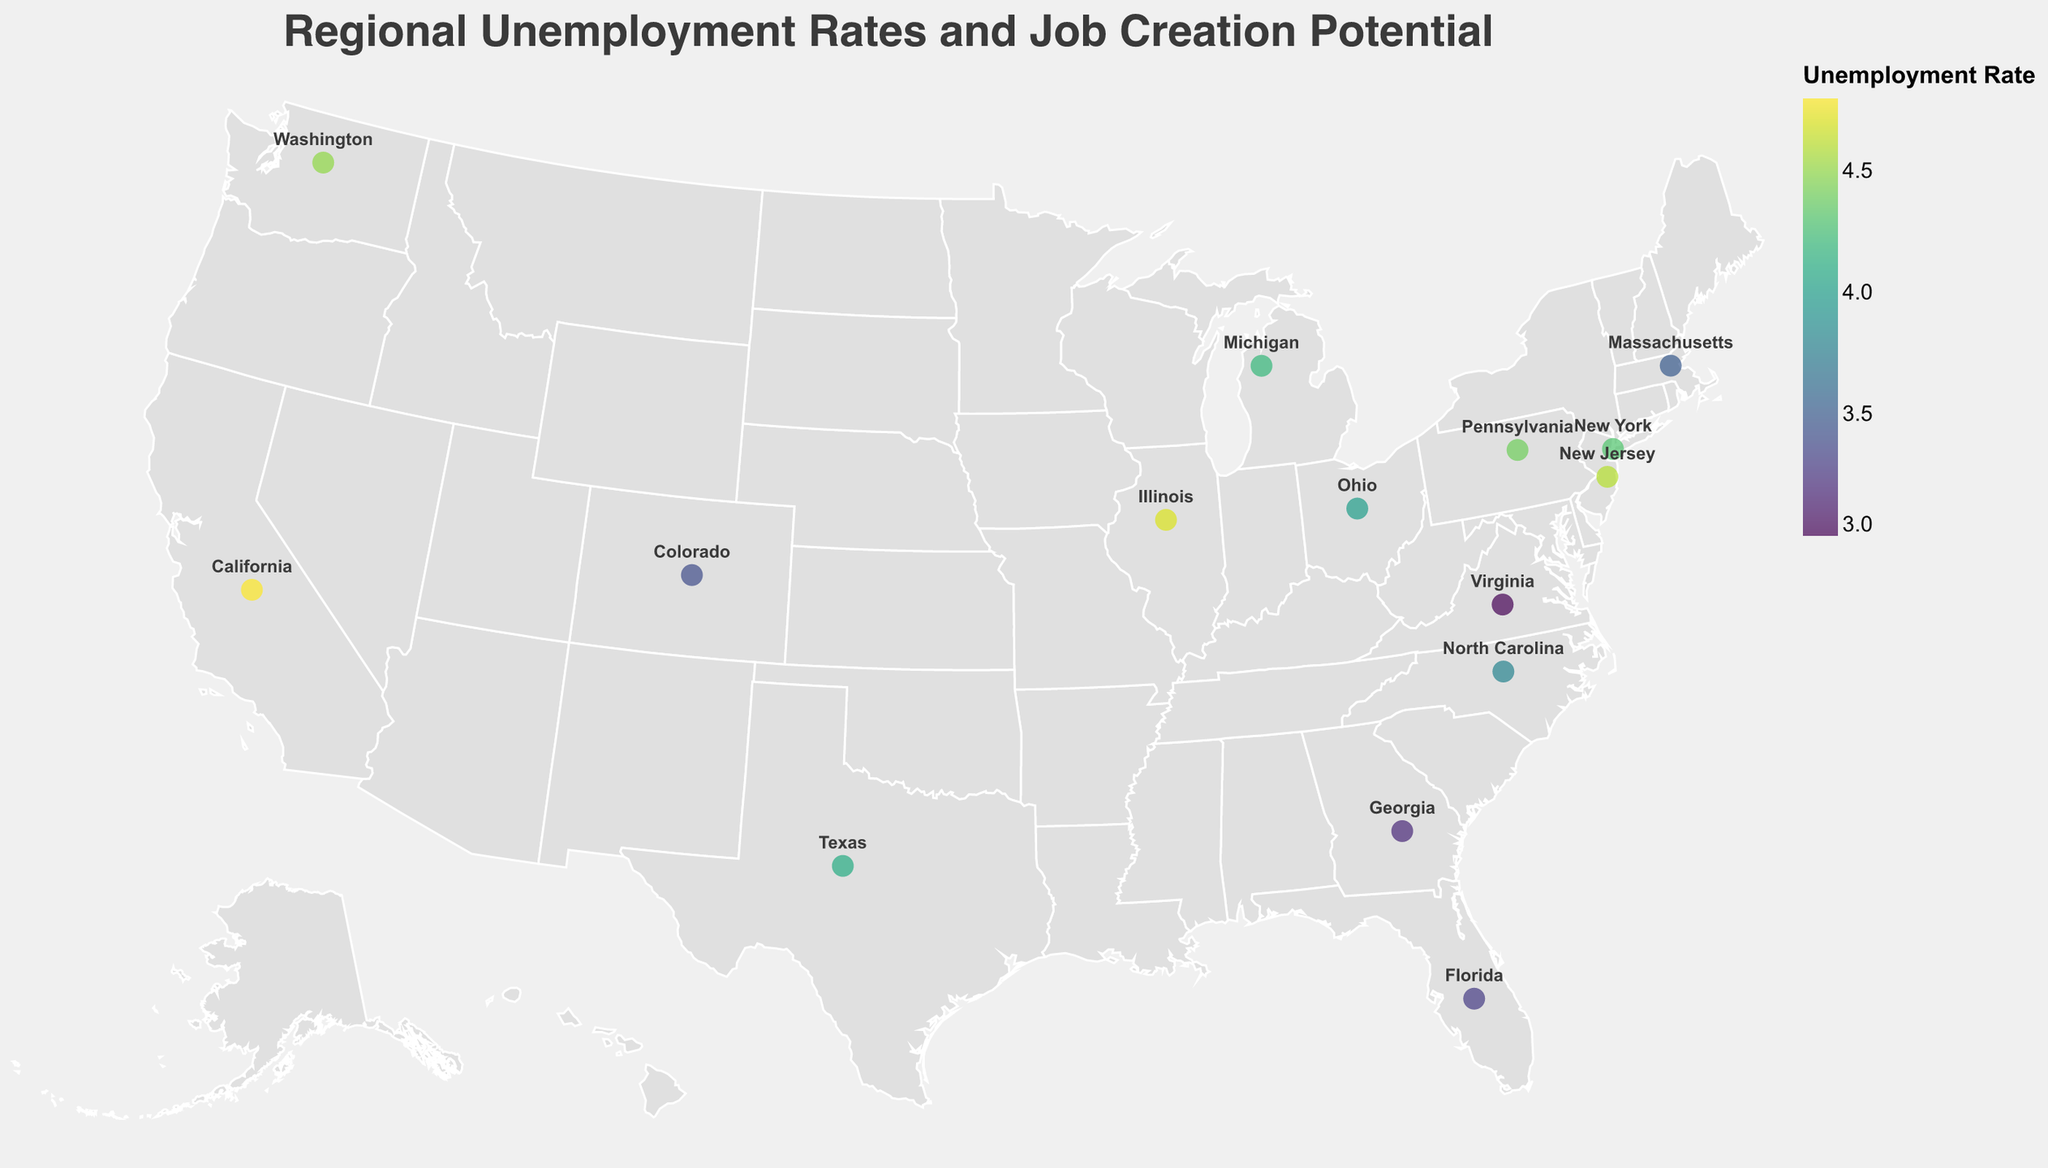What is the unemployment rate in California? Look at the data point labeled "California" and check the corresponding value for "Unemployment Rate."
Answer: 4.8% Which region has the lowest unemployment rate? Scan the data points for the "Unemployment Rate" and find the smallest number. Virginia has the smallest number, 3.0.
Answer: Virginia What is the top industry for job creation in Texas? Look at the data point labeled "Texas" and check the corresponding value for "Top Industry for Job Creation."
Answer: Energy Which regions have a job creation potential rated as "High"? Scan the data points for "Job Creation Potential" and identify the regions with the value "High." The regions are California, New York, North Carolina, Washington, New Jersey, and Colorado.
Answer: California, New York, North Carolina, Washington, New Jersey, Colorado Compare the unemployment rates of New York and Florida. Which one is higher? Look at the data points for New York and Florida and compare their values for "Unemployment Rate." New York has 4.3, and Florida has 3.3.
Answer: New York Which regions have an unemployment rate greater than 4.4%? Scan the data points for the "Unemployment Rate" and identify the regions with values greater than 4.4%. The regions are California, Illinois, Washington, and New Jersey.
Answer: California, Illinois, Washington, New Jersey What is the difference in unemployment rates between Ohio and Georgia? Look at the data points for Ohio and Georgia and subtract the smaller value from the larger one. Ohio has 4.0, and Georgia has 3.2, so 4.0 - 3.2 = 0.8.
Answer: 0.8 How many regions have a job creation potential rated as "Medium"? Count the data points where "Job Creation Potential" is "Medium." There are 8 such regions: Texas, Florida, Illinois, Pennsylvania, Michigan, Georgia, Massachusetts, and Pennsylvania.
Answer: 8 What is the average unemployment rate of regions with "High" job creation potential? Calculate the average of unemployment rates for regions with "High" job creation potential: (4.8 + 4.3 + 3.8 + 4.5 + 4.6 + 3.4) / 6 = 25.4 / 6 ≈ 4.23
Answer: 4.23 Which region has "Aerospace" as its top industry for job creation, and what is its unemployment rate? Find the region with "Aerospace" in the "Top Industry for Job Creation" and check its corresponding "Unemployment Rate." Washington has "Aerospace" with an unemployment rate of 4.5.
Answer: Washington, 4.5 